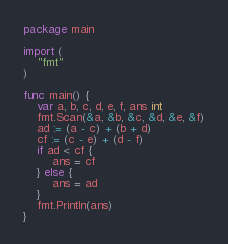Convert code to text. <code><loc_0><loc_0><loc_500><loc_500><_Go_>package main

import (
	"fmt"
)

func main() {
	var a, b, c, d, e, f, ans int
	fmt.Scan(&a, &b, &c, &d, &e, &f)
	ad := (a - c) + (b + d)
	cf := (c - e) + (d - f)
	if ad < cf {
		ans = cf
	} else {
		ans = ad
	}
	fmt.Println(ans)
}</code> 